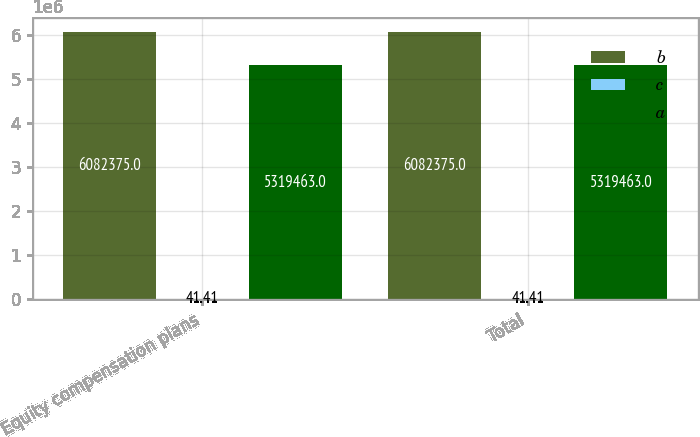Convert chart. <chart><loc_0><loc_0><loc_500><loc_500><stacked_bar_chart><ecel><fcel>Equity compensation plans<fcel>Total<nl><fcel>b<fcel>6.08238e+06<fcel>6.08238e+06<nl><fcel>c<fcel>41.41<fcel>41.41<nl><fcel>a<fcel>5.31946e+06<fcel>5.31946e+06<nl></chart> 